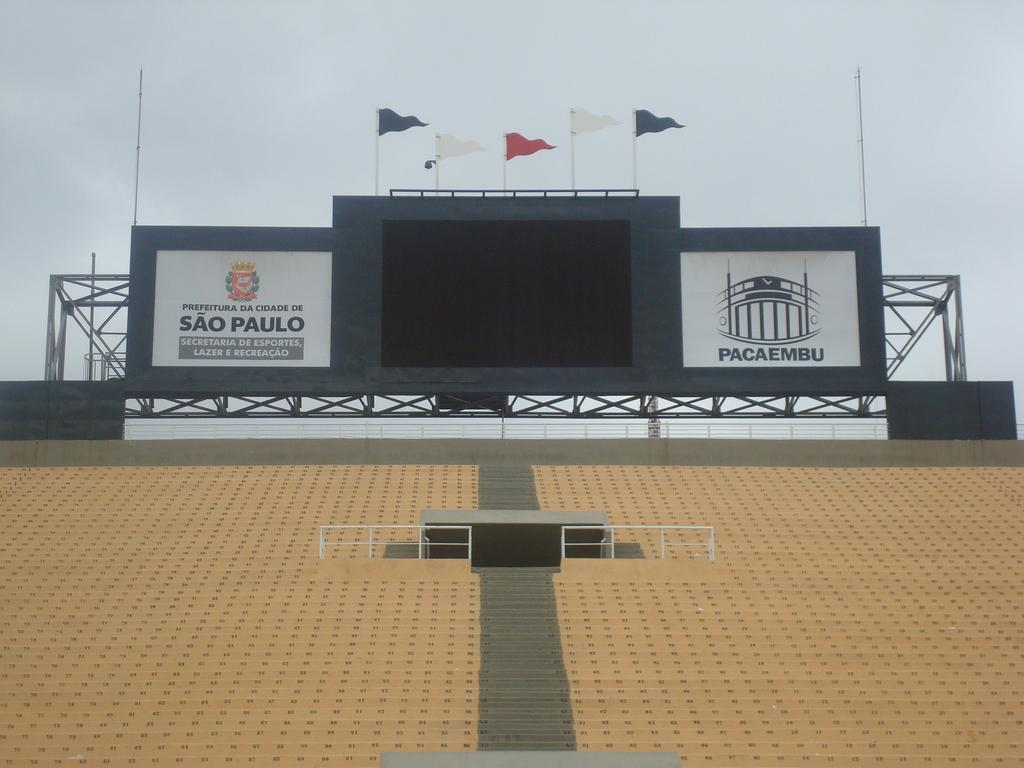<image>
Offer a succinct explanation of the picture presented. some bleachers that has a sao paulo advertisement on it 